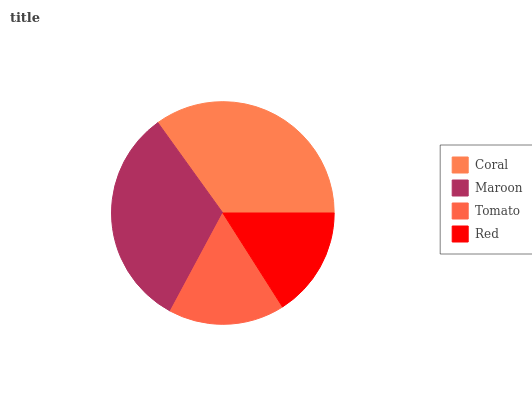Is Red the minimum?
Answer yes or no. Yes. Is Coral the maximum?
Answer yes or no. Yes. Is Maroon the minimum?
Answer yes or no. No. Is Maroon the maximum?
Answer yes or no. No. Is Coral greater than Maroon?
Answer yes or no. Yes. Is Maroon less than Coral?
Answer yes or no. Yes. Is Maroon greater than Coral?
Answer yes or no. No. Is Coral less than Maroon?
Answer yes or no. No. Is Maroon the high median?
Answer yes or no. Yes. Is Tomato the low median?
Answer yes or no. Yes. Is Tomato the high median?
Answer yes or no. No. Is Red the low median?
Answer yes or no. No. 